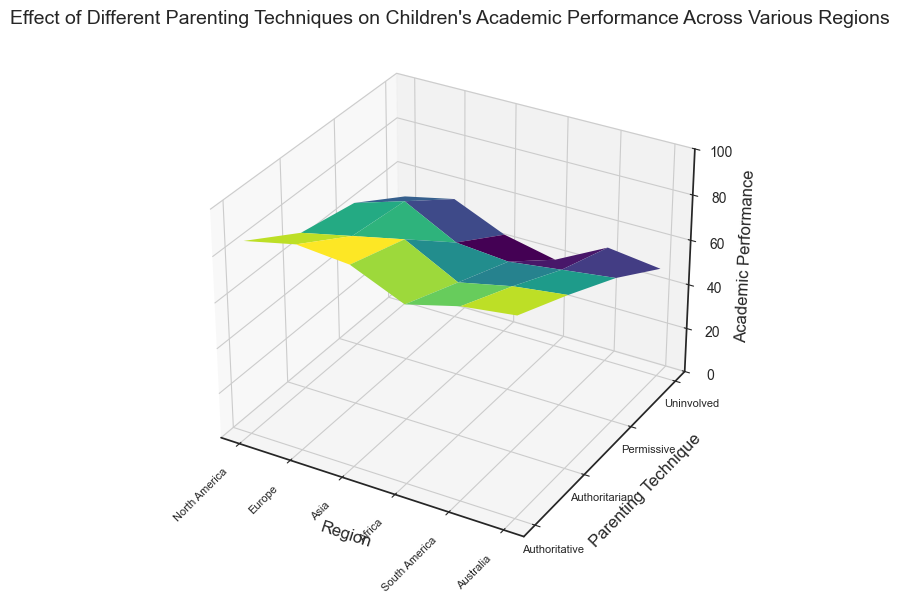What's the average academic performance for authoritative parenting technique? First, identify the academic performance values for the authoritative parenting technique in all regions: [85, 90, 88, 78, 84, 87]. Sum these values: (85 + 90 + 88 + 78 + 84 + 87) = 512. Then, divide by the number of values, which is 6. So, the average is 512 / 6 = 85.33.
Answer: 85.33 Which region shows the highest academic performance under the authoritarian parenting technique? Identify the academic performance values for the authoritarian parenting technique from all regions and compare them: North America (70), Europe (75), Asia (80), Africa (68), South America (73), Australia (76). The highest value is 80 in Asia.
Answer: Asia Does permissive parenting technique perform better in Europe or South America? Compare the academic performance values for the permissive parenting technique between Europe (72) and South America (61). Since 72 > 61, permissive parenting performs better in Europe.
Answer: Europe What is the range of academic performance in North America? Identify the academic performance values in North America: Authoritative (85), Authoritarian (70), Permissive (65), Uninvolved (50). The range is the difference between the highest and lowest values: 85 - 50 = 35.
Answer: 35 Which parenting technique leads to the lowest academic performance in Africa? Identify the academic performance values for each parenting technique in Africa: Authoritative (78), Authoritarian (68), Permissive (58), Uninvolved (40). The lowest value is 40, which corresponds to the uninvolved parenting technique.
Answer: Uninvolved Which region shows the most significant drop in academic performance between authoritative and uninvolved parenting techniques? Calculate the difference in academic performance between authoritative and uninvolved parenting techniques for each region: North America (85 - 50 = 35), Europe (90 - 55 = 35), Asia (88 - 45 = 43), Africa (78 - 40 = 38), South America (84 - 52 = 32), Australia (87 - 49 = 38). The most significant drop is 43 in Asia.
Answer: Asia How does academic performance in Australia compare between authoritative and permissive parenting techniques? Compare the academic performance values in Australia for authoritative (87) and permissive (64). Since 87 > 64, academic performance is higher under the authoritative parenting technique.
Answer: Authoritative What is the median academic performance value for permissive parenting technique across all regions? List the academic performance values for the permissive parenting technique across all regions: [65, 72, 60, 58, 61, 64]. Arrange the values in increasing order: [58, 60, 61, 64, 65, 72]. The median is the average of the two middle values: (61 + 64) / 2 = 62.5.
Answer: 62.5 